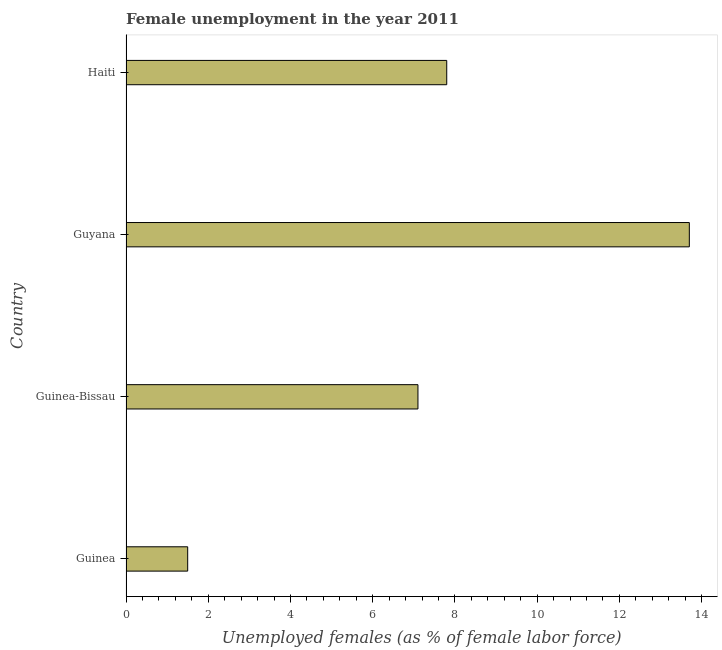Does the graph contain any zero values?
Your answer should be compact. No. What is the title of the graph?
Offer a terse response. Female unemployment in the year 2011. What is the label or title of the X-axis?
Ensure brevity in your answer.  Unemployed females (as % of female labor force). What is the unemployed females population in Guyana?
Your answer should be compact. 13.7. Across all countries, what is the maximum unemployed females population?
Keep it short and to the point. 13.7. In which country was the unemployed females population maximum?
Your answer should be compact. Guyana. In which country was the unemployed females population minimum?
Provide a succinct answer. Guinea. What is the sum of the unemployed females population?
Offer a terse response. 30.1. What is the average unemployed females population per country?
Ensure brevity in your answer.  7.53. What is the median unemployed females population?
Offer a very short reply. 7.45. In how many countries, is the unemployed females population greater than 4 %?
Ensure brevity in your answer.  3. What is the ratio of the unemployed females population in Guinea-Bissau to that in Guyana?
Provide a short and direct response. 0.52. What is the difference between the highest and the second highest unemployed females population?
Give a very brief answer. 5.9. In how many countries, is the unemployed females population greater than the average unemployed females population taken over all countries?
Give a very brief answer. 2. How many countries are there in the graph?
Your answer should be compact. 4. Are the values on the major ticks of X-axis written in scientific E-notation?
Offer a very short reply. No. What is the Unemployed females (as % of female labor force) in Guinea-Bissau?
Your answer should be compact. 7.1. What is the Unemployed females (as % of female labor force) in Guyana?
Your answer should be compact. 13.7. What is the Unemployed females (as % of female labor force) of Haiti?
Your answer should be compact. 7.8. What is the difference between the Unemployed females (as % of female labor force) in Guinea and Guyana?
Offer a terse response. -12.2. What is the difference between the Unemployed females (as % of female labor force) in Guinea and Haiti?
Ensure brevity in your answer.  -6.3. What is the difference between the Unemployed females (as % of female labor force) in Guinea-Bissau and Guyana?
Your answer should be very brief. -6.6. What is the difference between the Unemployed females (as % of female labor force) in Guinea-Bissau and Haiti?
Offer a very short reply. -0.7. What is the difference between the Unemployed females (as % of female labor force) in Guyana and Haiti?
Your answer should be compact. 5.9. What is the ratio of the Unemployed females (as % of female labor force) in Guinea to that in Guinea-Bissau?
Offer a very short reply. 0.21. What is the ratio of the Unemployed females (as % of female labor force) in Guinea to that in Guyana?
Offer a very short reply. 0.11. What is the ratio of the Unemployed females (as % of female labor force) in Guinea to that in Haiti?
Make the answer very short. 0.19. What is the ratio of the Unemployed females (as % of female labor force) in Guinea-Bissau to that in Guyana?
Make the answer very short. 0.52. What is the ratio of the Unemployed females (as % of female labor force) in Guinea-Bissau to that in Haiti?
Provide a succinct answer. 0.91. What is the ratio of the Unemployed females (as % of female labor force) in Guyana to that in Haiti?
Make the answer very short. 1.76. 